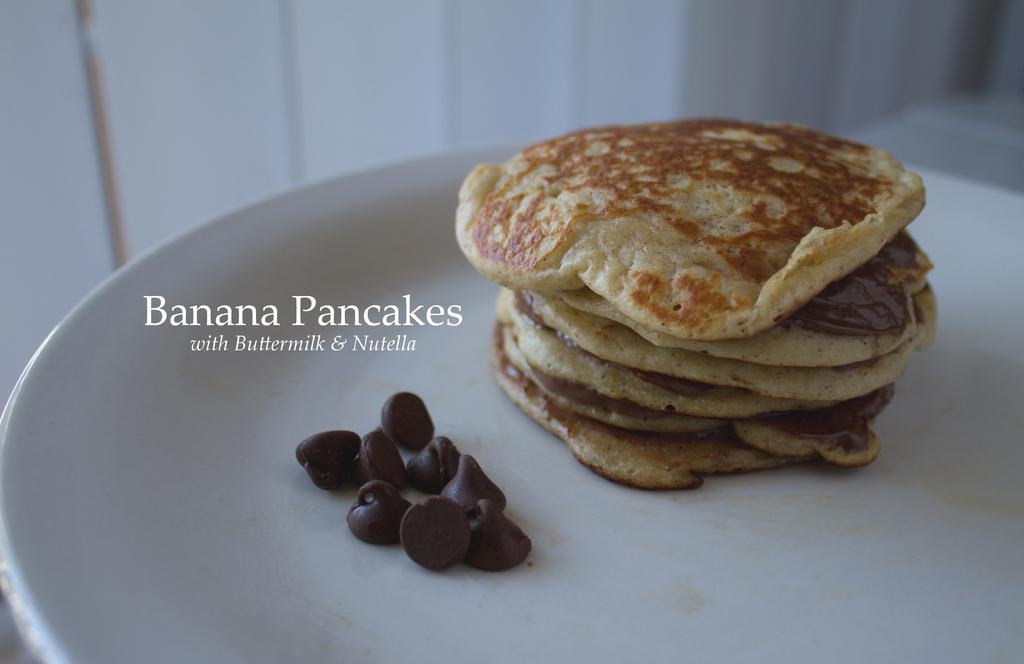What is on the white plate in the image? There are food items on a white plate in the image. What else can be seen in the image besides the plate? There is text visible in the image, and there is a wall in the background. How many cats are sitting on the tray in the image? There is no tray or cats present in the image. 